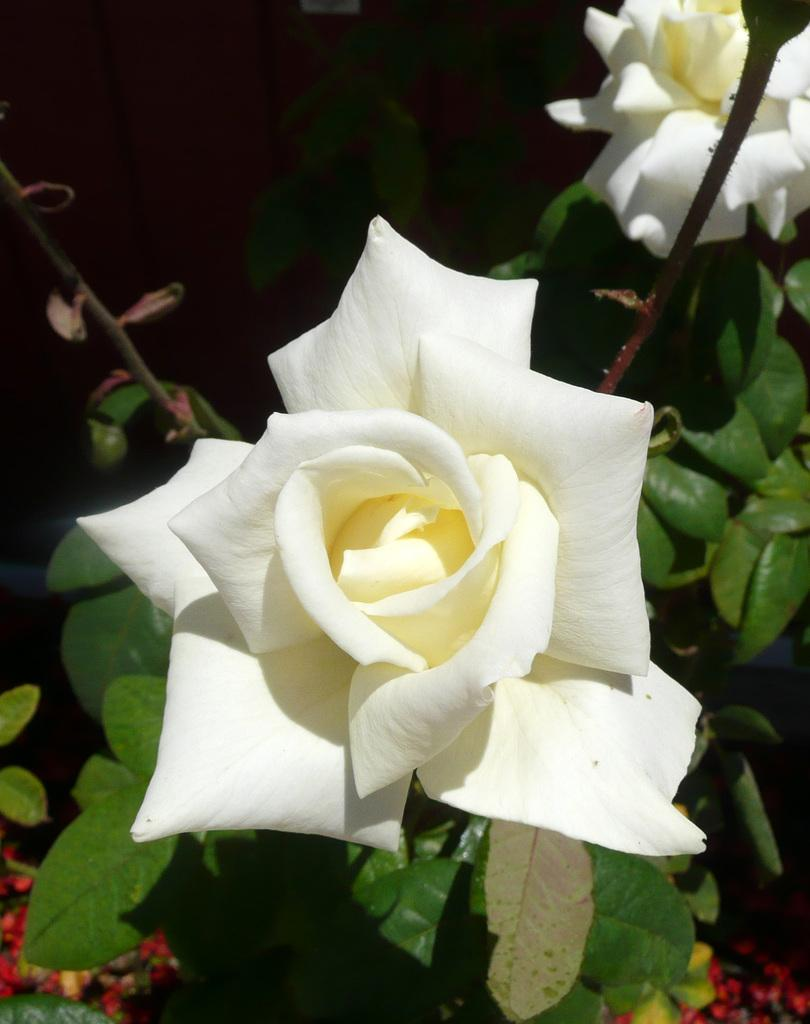What type of living organisms can be seen in the image? Flowers and plants can be seen in the image. Where are the flowers and plants located in the image? The flowers and plants are in the middle of the image. What type of rings can be seen on the flowers in the image? There are no rings present on the flowers in the image. What invention is responsible for the growth of the flowers and plants in the image? The image does not provide information about any specific invention responsible for the growth of the flowers and plants. 